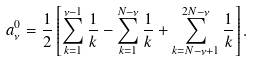<formula> <loc_0><loc_0><loc_500><loc_500>a _ { \nu } ^ { 0 } = \frac { 1 } { 2 } \left [ \sum _ { k = 1 } ^ { \nu - 1 } \frac { 1 } { k } - \sum _ { k = 1 } ^ { N - \nu } \frac { 1 } { k } + \sum _ { k = N - \nu + 1 } ^ { 2 N - \nu } \frac { 1 } { k } \right ] .</formula> 